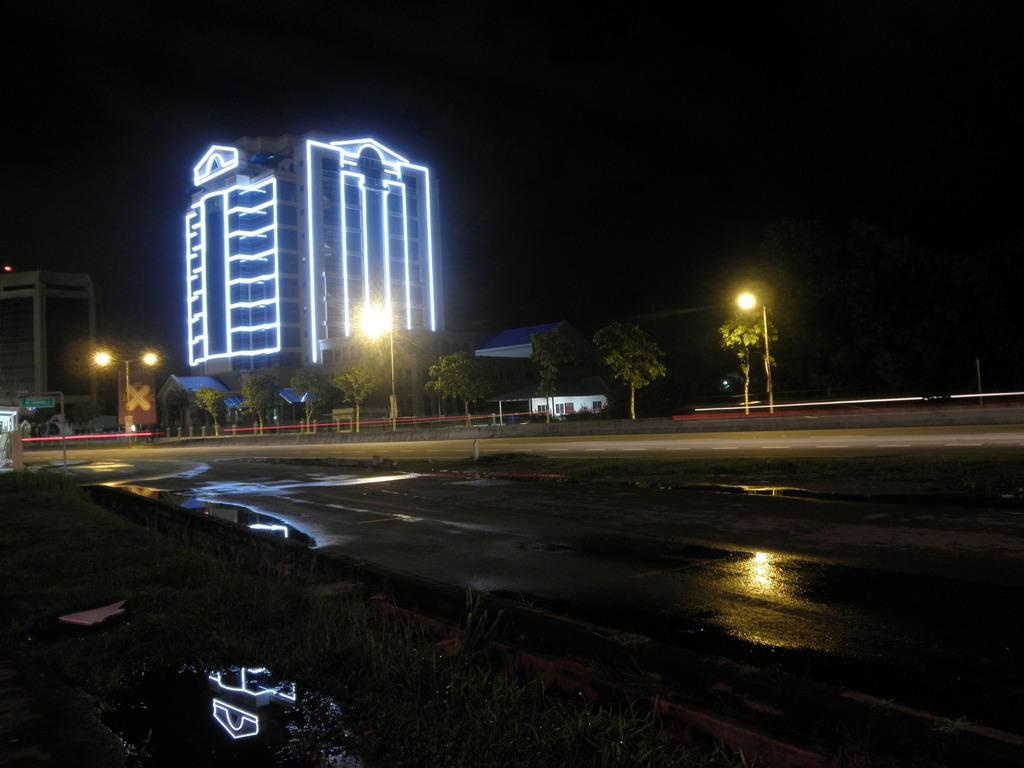What type of vegetation is present in the image? There is grass in the image. What type of transportation infrastructure can be seen in the image? There is a road in the image. What natural element is present in the image? There is water in the image. What type of plants are present in the image? There are trees in the image. What type of man-made structures are present in the image? There are poles and buildings in the image. What type of lighting is present in the image? There are street lights in the image. How would you describe the overall lighting in the image? The image appears to be slightly dark in the background. How many pets are visible in the image? There are no pets present in the image. What type of card is being used to pay for the street lights in the image? There is no card or payment system depicted in the image; the street lights are simply present. 